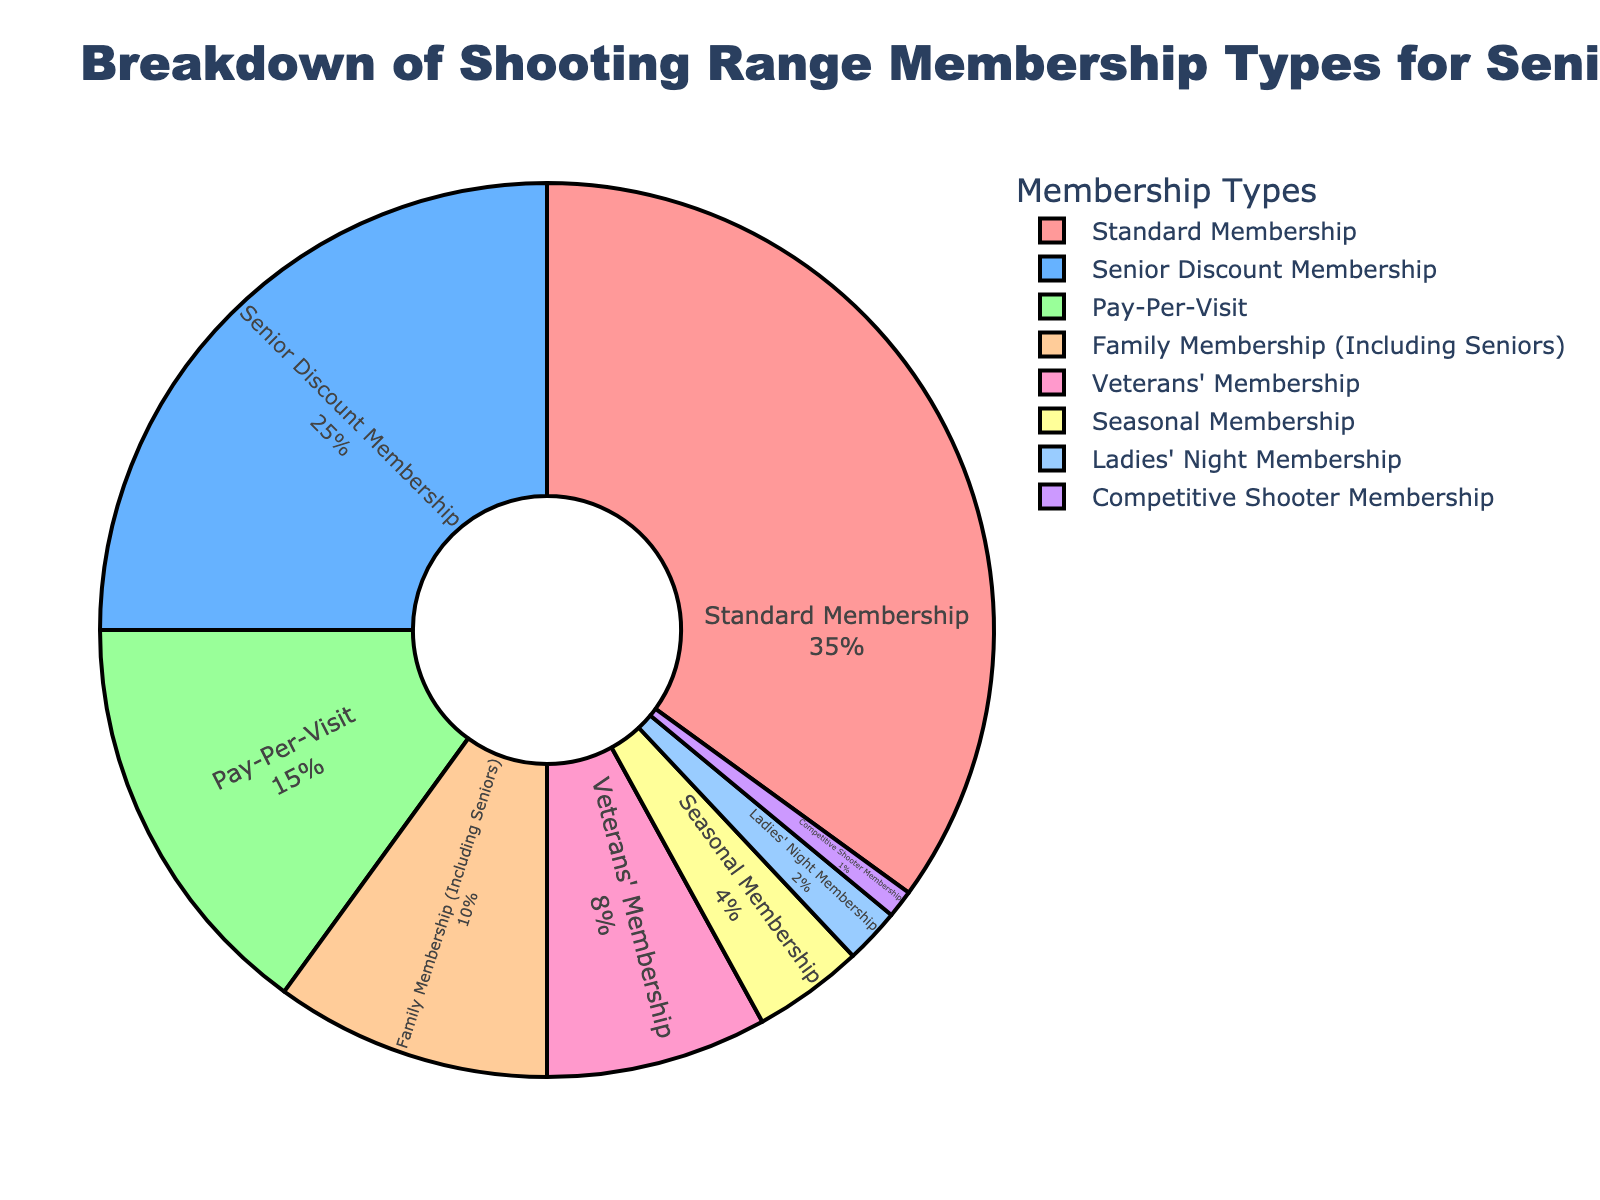Which membership type has the highest percentage? Look at the pie chart and identify the segment with the largest size. The label "Standard Membership" shows it has the highest value at 35%.
Answer: Standard Membership Which membership types together make up more than half of the total members? Sum the percentages of the membership types starting from the highest until the total exceeds 50%. Standard Membership is 35%, adding Senior Discount Membership 25% reaches 60%.
Answer: Standard Membership, Senior Discount Membership What is the difference in percentage between Pay-Per-Visit and Family Membership (Including Seniors)? Subtract the percentage of Family Membership (10%) from the percentage of Pay-Per-Visit (15%).
Answer: 5% How many times larger is the percentage of Family Membership (Including Seniors) compared to Competitive Shooter Membership? Divide the percentage of Family Membership (10%) by that of Competitive Shooter Membership (1%).
Answer: 10 times Which membership type is represented by the pink segment? Observe the segment colored pink, which corresponds to "Standard Membership" listed in the legend.
Answer: Standard Membership Comparing Senior Discount Membership to Veterans' Membership, which one has a greater percentage and by how much? Subtract the percentage of Veterans' Membership (8%) from Senior Discount Membership (25%) to find the difference.
Answer: Senior Discount Membership by 17% What is the sum of percentages for the three smallest membership types? Add the percentages of Seasonal Membership (4%), Ladies' Night Membership (2%), and Competitive Shooter Membership (1%).
Answer: 7% If you combine the percentages of Pay-Per-Visit and Veterans' Membership, do they equal to or exceed the percentage of Senior Discount Membership? Add the percentages of Pay-Per-Visit (15%) and Veterans' Membership (8%) to see if the result (23%) is less than the percentage of Senior Discount Membership (25%).
Answer: No, they do not Which membership type has approximately half the percentage of Standard Membership? Calculate half of Standard Membership's percentage (35%) which is 17.5%, and find the type closest to this value. Senior Discount Membership at 25% is not approximate, only Family Membership (10%) and Veterans' Membership (8%) are similar halves.
Answer: Veterans' Membership 